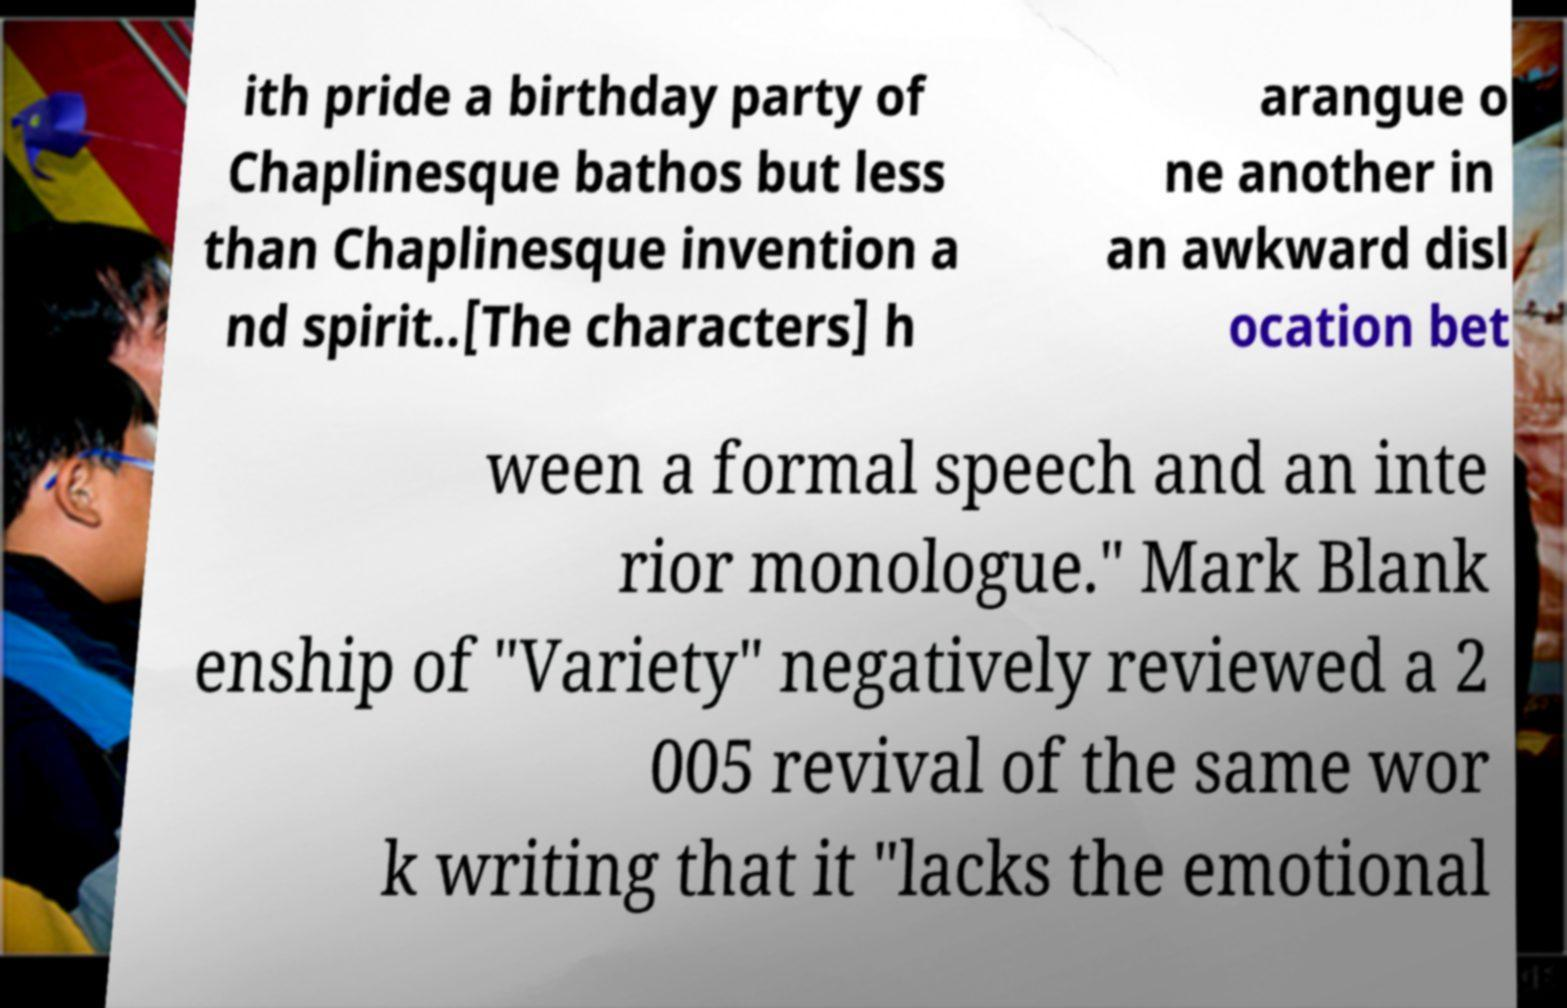Can you accurately transcribe the text from the provided image for me? ith pride a birthday party of Chaplinesque bathos but less than Chaplinesque invention a nd spirit..[The characters] h arangue o ne another in an awkward disl ocation bet ween a formal speech and an inte rior monologue." Mark Blank enship of "Variety" negatively reviewed a 2 005 revival of the same wor k writing that it "lacks the emotional 